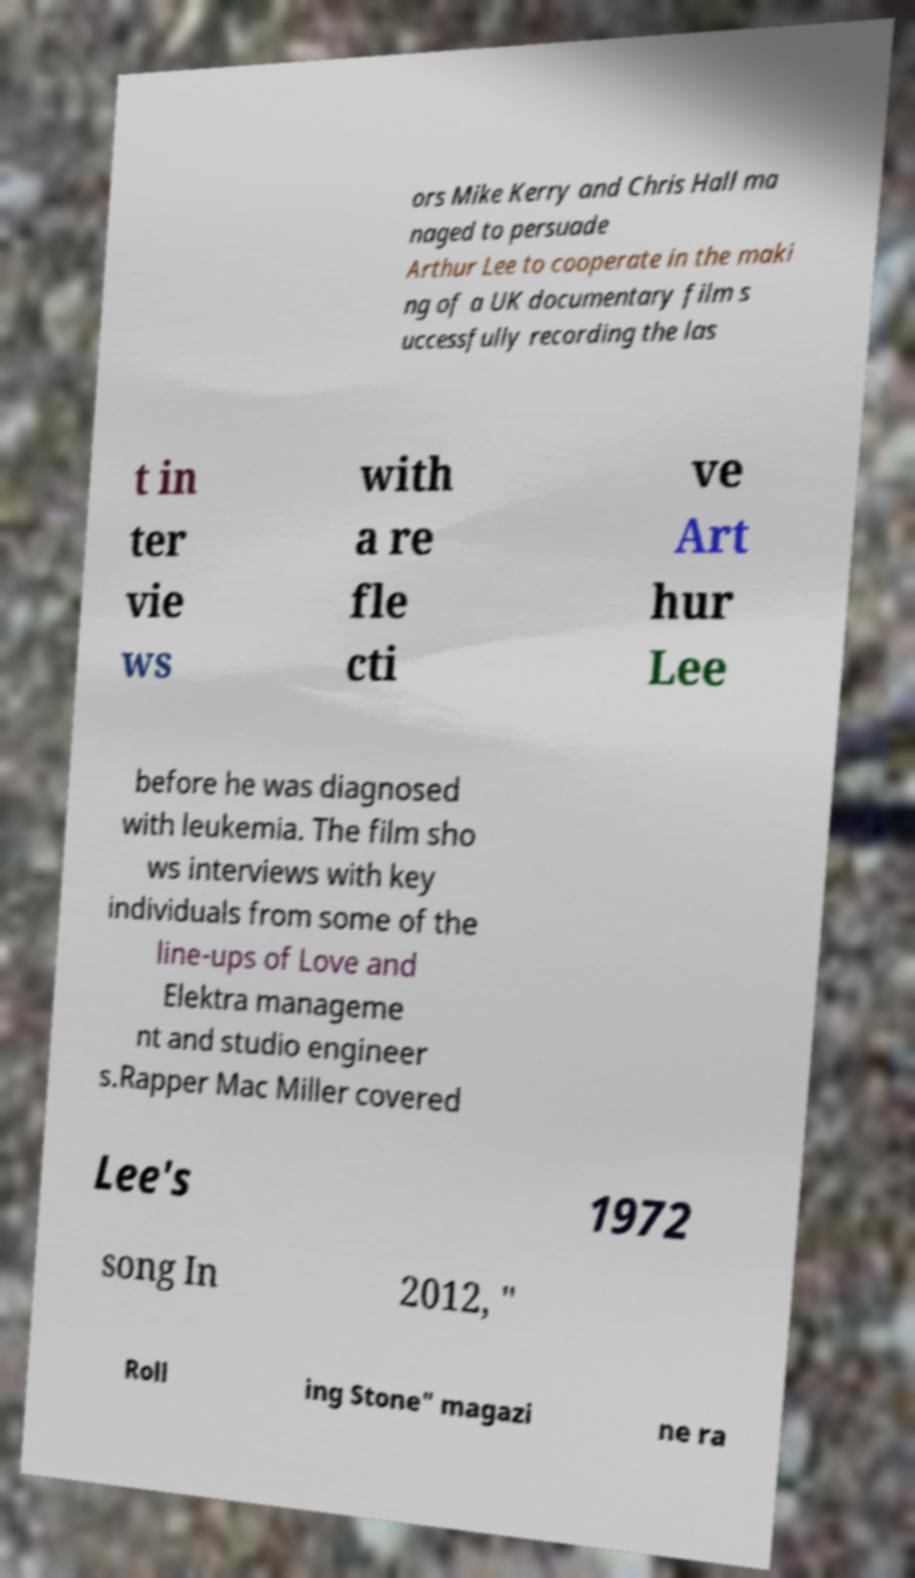What messages or text are displayed in this image? I need them in a readable, typed format. ors Mike Kerry and Chris Hall ma naged to persuade Arthur Lee to cooperate in the maki ng of a UK documentary film s uccessfully recording the las t in ter vie ws with a re fle cti ve Art hur Lee before he was diagnosed with leukemia. The film sho ws interviews with key individuals from some of the line-ups of Love and Elektra manageme nt and studio engineer s.Rapper Mac Miller covered Lee's 1972 song In 2012, " Roll ing Stone" magazi ne ra 